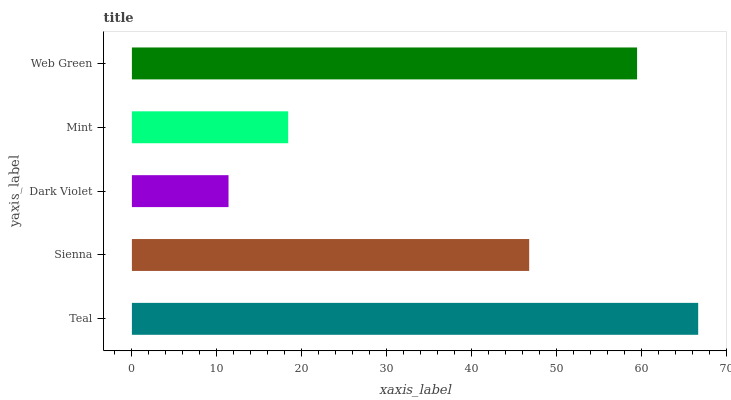Is Dark Violet the minimum?
Answer yes or no. Yes. Is Teal the maximum?
Answer yes or no. Yes. Is Sienna the minimum?
Answer yes or no. No. Is Sienna the maximum?
Answer yes or no. No. Is Teal greater than Sienna?
Answer yes or no. Yes. Is Sienna less than Teal?
Answer yes or no. Yes. Is Sienna greater than Teal?
Answer yes or no. No. Is Teal less than Sienna?
Answer yes or no. No. Is Sienna the high median?
Answer yes or no. Yes. Is Sienna the low median?
Answer yes or no. Yes. Is Mint the high median?
Answer yes or no. No. Is Teal the low median?
Answer yes or no. No. 